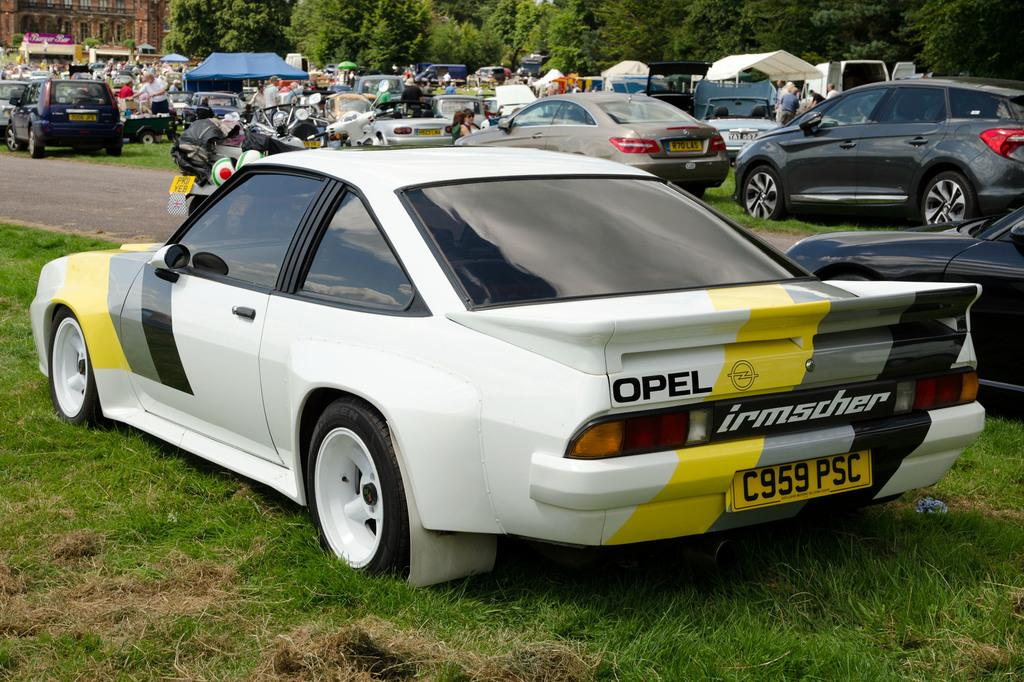What types of vehicles are on the ground in the image? There are motor vehicles on the ground in the image. What objects are providing shade in the image? There are parasols in the image. What are the people in the image doing? There are persons standing on the ground in the image. What structures can be seen in the image? There are buildings in the image. What type of vegetation is present in the image? There are trees in the image. Are there any horses visible in the image? No, there are no horses present in the image. What position are the trees in the image? The trees are stationary in the image, as they are plants and do not have the ability to change positions. 